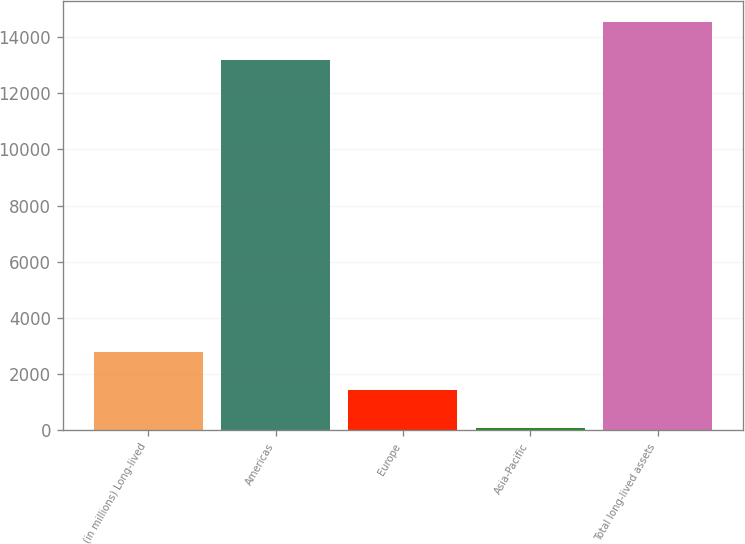Convert chart. <chart><loc_0><loc_0><loc_500><loc_500><bar_chart><fcel>(in millions) Long-lived<fcel>Americas<fcel>Europe<fcel>Asia-Pacific<fcel>Total long-lived assets<nl><fcel>2770.6<fcel>13204<fcel>1428.8<fcel>87<fcel>14545.8<nl></chart> 